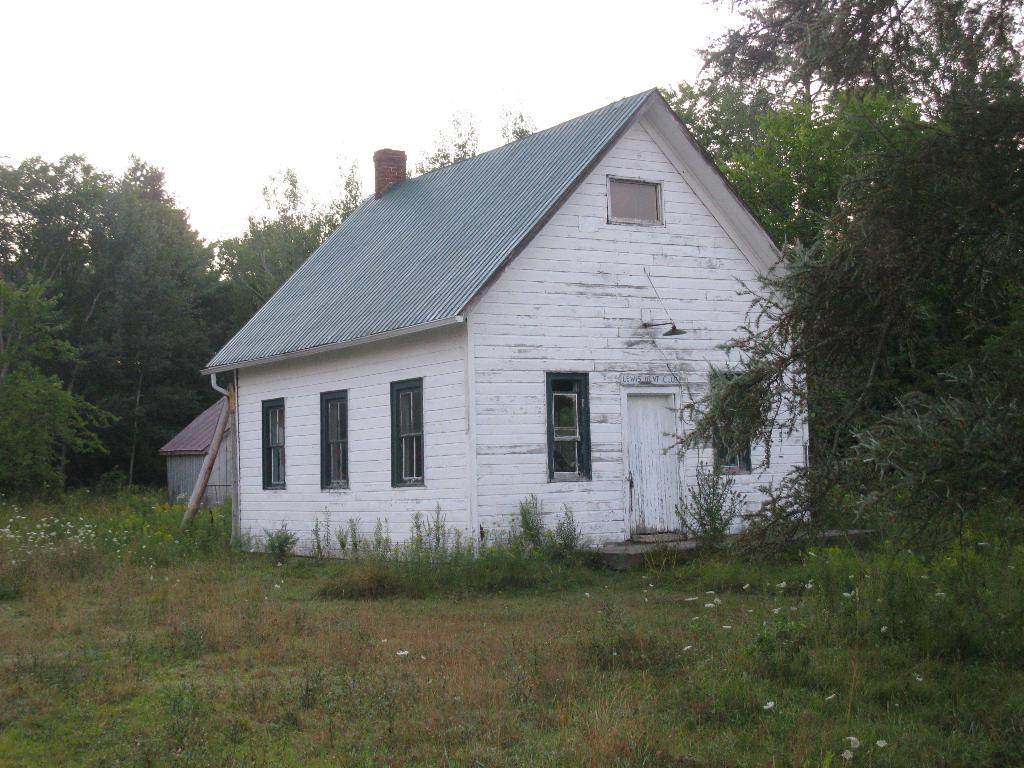What is the main subject of the image? The main subject of the image is a house. What can be seen around the house? There is greenery around the house, including trees, plants, and grass. What is visible in the background of the image? The sky is visible in the background of the image. What type of lunch is being served at the house in the image? There is no indication of any lunch being served in the image; it only shows a house with greenery and the sky in the background. 